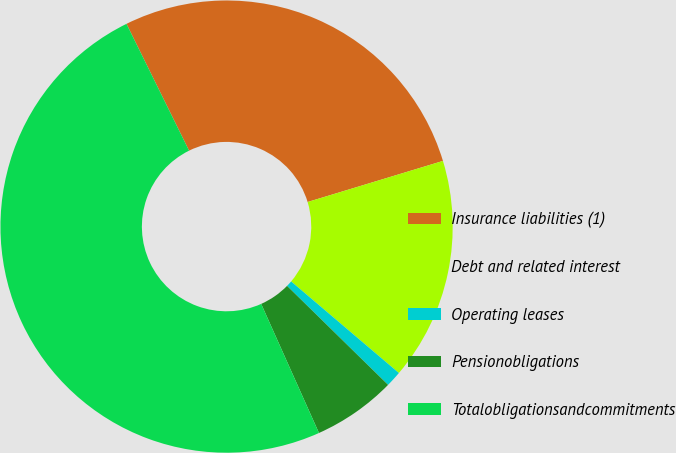Convert chart to OTSL. <chart><loc_0><loc_0><loc_500><loc_500><pie_chart><fcel>Insurance liabilities (1)<fcel>Debt and related interest<fcel>Operating leases<fcel>Pensionobligations<fcel>Totalobligationsandcommitments<nl><fcel>27.61%<fcel>15.9%<fcel>1.13%<fcel>5.96%<fcel>49.4%<nl></chart> 